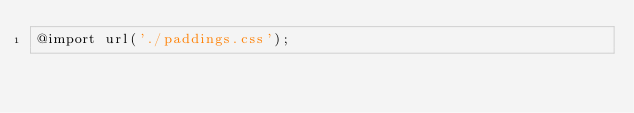Convert code to text. <code><loc_0><loc_0><loc_500><loc_500><_CSS_>@import url('./paddings.css');</code> 